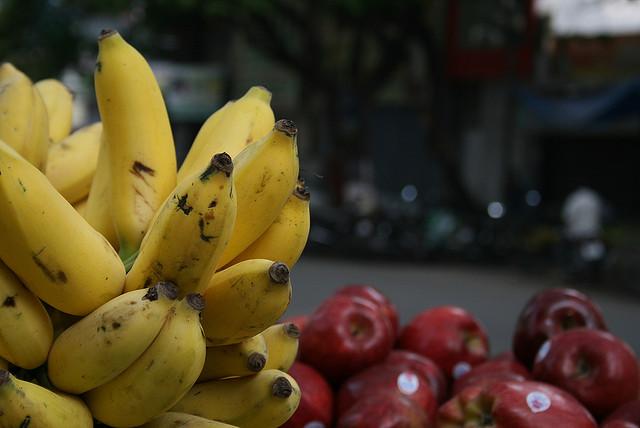What color are the bananas?
Short answer required. Yellow. Are these ripe?
Keep it brief. Yes. What color are the apples?
Be succinct. Red. What purple fruit is shown?
Be succinct. Apple. Are the bananas ripe?
Write a very short answer. Yes. How many types of fruit are shown?
Concise answer only. 2. 